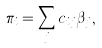<formula> <loc_0><loc_0><loc_500><loc_500>\pi _ { i } = \sum _ { j } c _ { i j } \beta _ { j } ,</formula> 